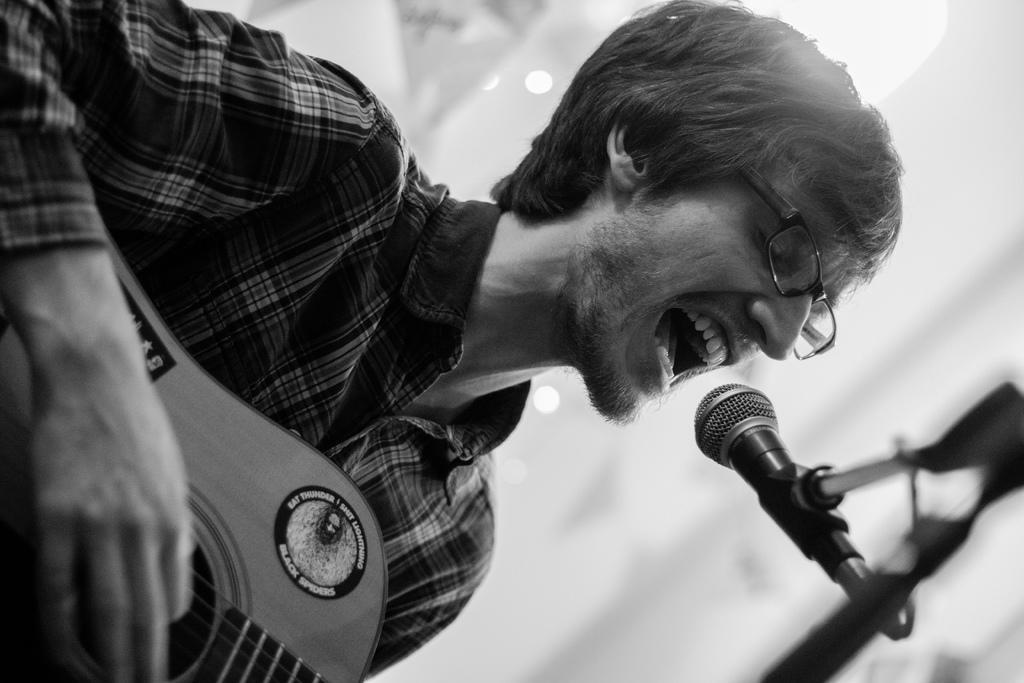Describe this image in one or two sentences. In this picture there is a man playing a guitar and singing. There is a mic. 